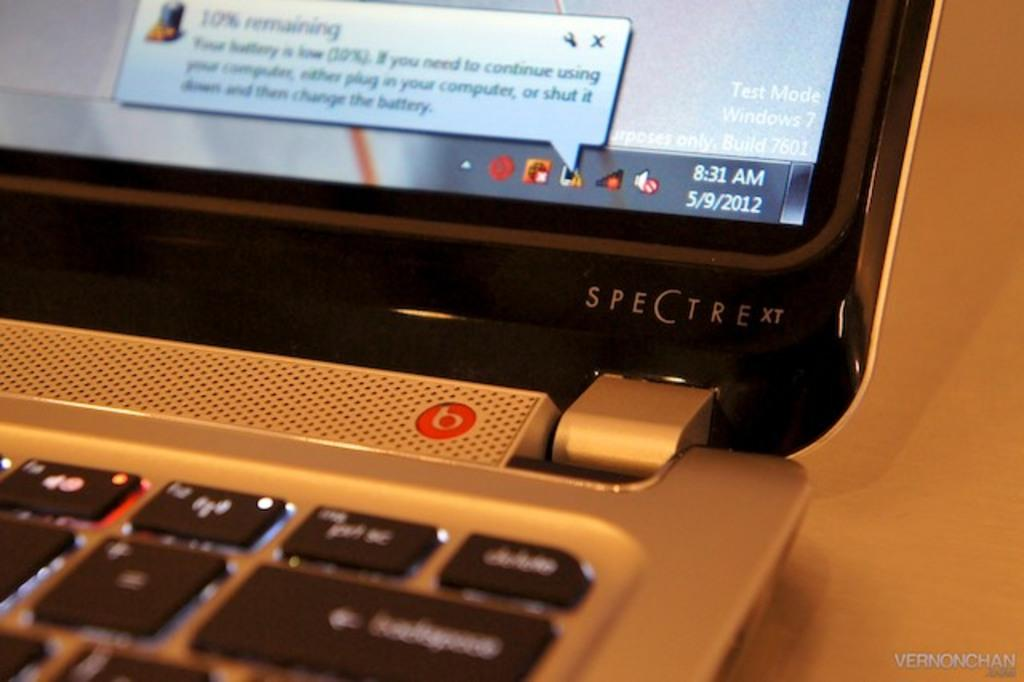What electronic device is present in the image? There is a laptop in the image. What part of the laptop is visible and allows for input? Keys are visible in the image, which are used for input. What part of the laptop displays information? There is a screen visible in the image, which displays information. What type of baseball is shown on the laptop screen in the image? There is no baseball present in the image, as it features a laptop with keys and a screen. 